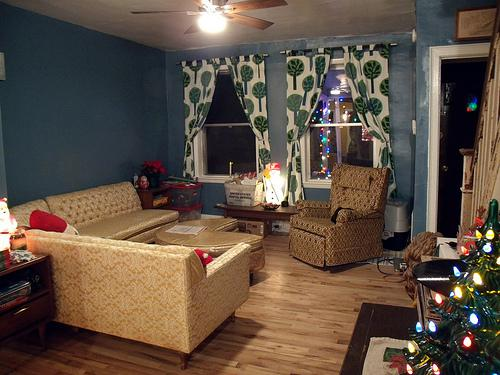Question: when was this picture taken?
Choices:
A. At noon.
B. At sunset.
C. At sunrise.
D. At night.
Answer with the letter. Answer: D Question: what color is the walls?
Choices:
A. Beige.
B. White.
C. Black.
D. They are blue.
Answer with the letter. Answer: D Question: how is the curtains hanging?
Choices:
A. On rods.
B. On a rope.
C. Nails.
D. Velcro.
Answer with the letter. Answer: A Question: what time of the year is this?
Choices:
A. Summer.
B. It's christmas.
C. Halloween.
D. Spring.
Answer with the letter. Answer: B Question: why the curtains open?
Choices:
A. To show off the lights.
B. Exhibisionist.
C. Reveal prize.
D. Start the play.
Answer with the letter. Answer: A Question: what kind of floor do they have?
Choices:
A. Carpet.
B. Linoleum.
C. Tile.
D. They hardwood.
Answer with the letter. Answer: D 